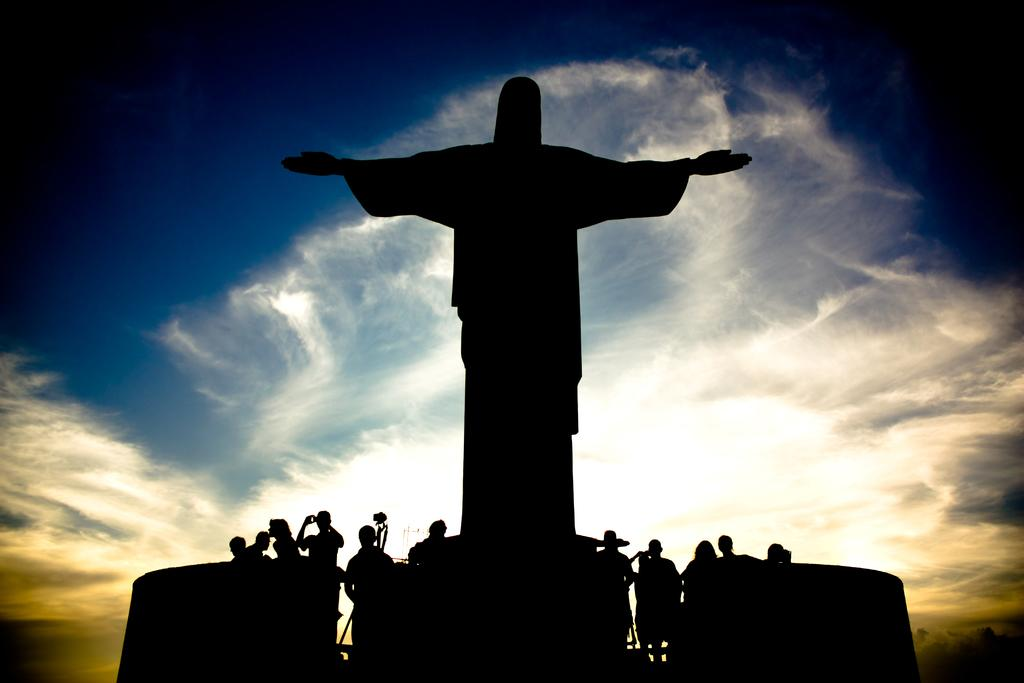Where was the image taken? The image was clicked outside. What can be seen at the bottom of the image? There are people at the bottom of the image. What is the main subject in the middle of the image? There is a statue of Jesus Christ in the middle of the image. What is visible at the top of the image? The sky is visible at the top of the image. What color is the goose's tail in the image? There is no goose or tail present in the image. What is the desire of the statue of Jesus Christ in the image? The statue of Jesus Christ is an inanimate object and does not have desires. 